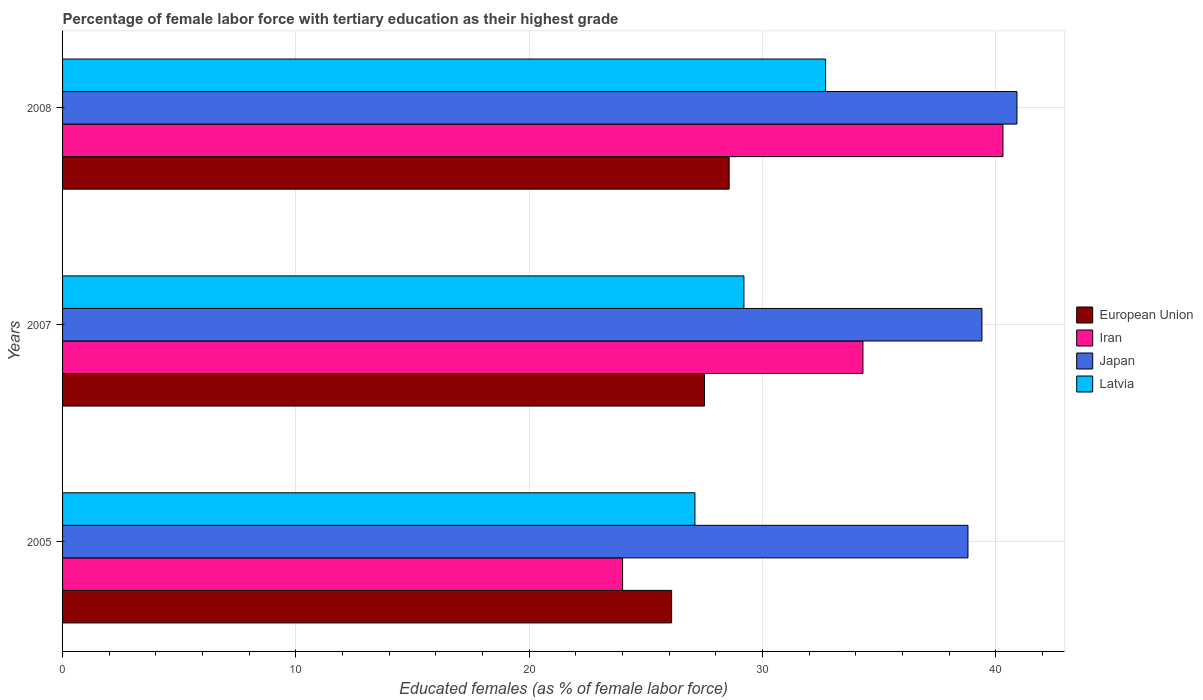How many groups of bars are there?
Your answer should be compact. 3. Are the number of bars per tick equal to the number of legend labels?
Your answer should be very brief. Yes. How many bars are there on the 2nd tick from the top?
Your response must be concise. 4. How many bars are there on the 1st tick from the bottom?
Offer a very short reply. 4. What is the label of the 1st group of bars from the top?
Give a very brief answer. 2008. In how many cases, is the number of bars for a given year not equal to the number of legend labels?
Offer a very short reply. 0. What is the percentage of female labor force with tertiary education in European Union in 2008?
Offer a terse response. 28.57. Across all years, what is the maximum percentage of female labor force with tertiary education in Iran?
Provide a short and direct response. 40.3. In which year was the percentage of female labor force with tertiary education in Latvia maximum?
Offer a terse response. 2008. In which year was the percentage of female labor force with tertiary education in Japan minimum?
Make the answer very short. 2005. What is the total percentage of female labor force with tertiary education in Latvia in the graph?
Keep it short and to the point. 89. What is the difference between the percentage of female labor force with tertiary education in European Union in 2007 and that in 2008?
Your answer should be compact. -1.06. What is the average percentage of female labor force with tertiary education in Iran per year?
Offer a very short reply. 32.87. In the year 2005, what is the difference between the percentage of female labor force with tertiary education in European Union and percentage of female labor force with tertiary education in Japan?
Keep it short and to the point. -12.7. What is the ratio of the percentage of female labor force with tertiary education in Latvia in 2005 to that in 2007?
Provide a short and direct response. 0.93. Is the percentage of female labor force with tertiary education in European Union in 2007 less than that in 2008?
Make the answer very short. Yes. Is the difference between the percentage of female labor force with tertiary education in European Union in 2005 and 2008 greater than the difference between the percentage of female labor force with tertiary education in Japan in 2005 and 2008?
Give a very brief answer. No. What is the difference between the highest and the second highest percentage of female labor force with tertiary education in Latvia?
Ensure brevity in your answer.  3.5. What is the difference between the highest and the lowest percentage of female labor force with tertiary education in Latvia?
Keep it short and to the point. 5.6. Is the sum of the percentage of female labor force with tertiary education in Iran in 2005 and 2008 greater than the maximum percentage of female labor force with tertiary education in European Union across all years?
Give a very brief answer. Yes. Is it the case that in every year, the sum of the percentage of female labor force with tertiary education in Latvia and percentage of female labor force with tertiary education in Japan is greater than the sum of percentage of female labor force with tertiary education in European Union and percentage of female labor force with tertiary education in Iran?
Offer a terse response. No. What does the 1st bar from the top in 2005 represents?
Offer a terse response. Latvia. What does the 2nd bar from the bottom in 2007 represents?
Offer a very short reply. Iran. How many bars are there?
Provide a short and direct response. 12. Are all the bars in the graph horizontal?
Provide a short and direct response. Yes. How many years are there in the graph?
Provide a succinct answer. 3. Are the values on the major ticks of X-axis written in scientific E-notation?
Ensure brevity in your answer.  No. Does the graph contain any zero values?
Your answer should be compact. No. How many legend labels are there?
Make the answer very short. 4. What is the title of the graph?
Keep it short and to the point. Percentage of female labor force with tertiary education as their highest grade. Does "American Samoa" appear as one of the legend labels in the graph?
Provide a succinct answer. No. What is the label or title of the X-axis?
Keep it short and to the point. Educated females (as % of female labor force). What is the Educated females (as % of female labor force) in European Union in 2005?
Give a very brief answer. 26.1. What is the Educated females (as % of female labor force) of Iran in 2005?
Ensure brevity in your answer.  24. What is the Educated females (as % of female labor force) of Japan in 2005?
Offer a terse response. 38.8. What is the Educated females (as % of female labor force) of Latvia in 2005?
Ensure brevity in your answer.  27.1. What is the Educated females (as % of female labor force) in European Union in 2007?
Your response must be concise. 27.51. What is the Educated females (as % of female labor force) in Iran in 2007?
Keep it short and to the point. 34.3. What is the Educated females (as % of female labor force) of Japan in 2007?
Keep it short and to the point. 39.4. What is the Educated females (as % of female labor force) in Latvia in 2007?
Offer a very short reply. 29.2. What is the Educated females (as % of female labor force) of European Union in 2008?
Ensure brevity in your answer.  28.57. What is the Educated females (as % of female labor force) in Iran in 2008?
Your answer should be compact. 40.3. What is the Educated females (as % of female labor force) of Japan in 2008?
Make the answer very short. 40.9. What is the Educated females (as % of female labor force) of Latvia in 2008?
Keep it short and to the point. 32.7. Across all years, what is the maximum Educated females (as % of female labor force) of European Union?
Your response must be concise. 28.57. Across all years, what is the maximum Educated females (as % of female labor force) of Iran?
Keep it short and to the point. 40.3. Across all years, what is the maximum Educated females (as % of female labor force) in Japan?
Your response must be concise. 40.9. Across all years, what is the maximum Educated females (as % of female labor force) of Latvia?
Give a very brief answer. 32.7. Across all years, what is the minimum Educated females (as % of female labor force) of European Union?
Ensure brevity in your answer.  26.1. Across all years, what is the minimum Educated females (as % of female labor force) in Japan?
Offer a very short reply. 38.8. Across all years, what is the minimum Educated females (as % of female labor force) in Latvia?
Make the answer very short. 27.1. What is the total Educated females (as % of female labor force) in European Union in the graph?
Provide a short and direct response. 82.18. What is the total Educated females (as % of female labor force) of Iran in the graph?
Offer a terse response. 98.6. What is the total Educated females (as % of female labor force) in Japan in the graph?
Keep it short and to the point. 119.1. What is the total Educated females (as % of female labor force) in Latvia in the graph?
Your response must be concise. 89. What is the difference between the Educated females (as % of female labor force) of European Union in 2005 and that in 2007?
Provide a short and direct response. -1.41. What is the difference between the Educated females (as % of female labor force) in Iran in 2005 and that in 2007?
Offer a very short reply. -10.3. What is the difference between the Educated females (as % of female labor force) of Japan in 2005 and that in 2007?
Keep it short and to the point. -0.6. What is the difference between the Educated females (as % of female labor force) in Latvia in 2005 and that in 2007?
Offer a very short reply. -2.1. What is the difference between the Educated females (as % of female labor force) of European Union in 2005 and that in 2008?
Offer a very short reply. -2.46. What is the difference between the Educated females (as % of female labor force) in Iran in 2005 and that in 2008?
Make the answer very short. -16.3. What is the difference between the Educated females (as % of female labor force) in Japan in 2005 and that in 2008?
Make the answer very short. -2.1. What is the difference between the Educated females (as % of female labor force) of Latvia in 2005 and that in 2008?
Your response must be concise. -5.6. What is the difference between the Educated females (as % of female labor force) in European Union in 2007 and that in 2008?
Ensure brevity in your answer.  -1.06. What is the difference between the Educated females (as % of female labor force) of Iran in 2007 and that in 2008?
Keep it short and to the point. -6. What is the difference between the Educated females (as % of female labor force) of Japan in 2007 and that in 2008?
Make the answer very short. -1.5. What is the difference between the Educated females (as % of female labor force) of European Union in 2005 and the Educated females (as % of female labor force) of Iran in 2007?
Give a very brief answer. -8.2. What is the difference between the Educated females (as % of female labor force) in European Union in 2005 and the Educated females (as % of female labor force) in Japan in 2007?
Offer a very short reply. -13.3. What is the difference between the Educated females (as % of female labor force) of European Union in 2005 and the Educated females (as % of female labor force) of Latvia in 2007?
Give a very brief answer. -3.1. What is the difference between the Educated females (as % of female labor force) of Iran in 2005 and the Educated females (as % of female labor force) of Japan in 2007?
Your answer should be very brief. -15.4. What is the difference between the Educated females (as % of female labor force) in Iran in 2005 and the Educated females (as % of female labor force) in Latvia in 2007?
Your answer should be compact. -5.2. What is the difference between the Educated females (as % of female labor force) of European Union in 2005 and the Educated females (as % of female labor force) of Iran in 2008?
Keep it short and to the point. -14.2. What is the difference between the Educated females (as % of female labor force) of European Union in 2005 and the Educated females (as % of female labor force) of Japan in 2008?
Your response must be concise. -14.8. What is the difference between the Educated females (as % of female labor force) in European Union in 2005 and the Educated females (as % of female labor force) in Latvia in 2008?
Provide a succinct answer. -6.6. What is the difference between the Educated females (as % of female labor force) in Iran in 2005 and the Educated females (as % of female labor force) in Japan in 2008?
Offer a very short reply. -16.9. What is the difference between the Educated females (as % of female labor force) in European Union in 2007 and the Educated females (as % of female labor force) in Iran in 2008?
Provide a short and direct response. -12.79. What is the difference between the Educated females (as % of female labor force) in European Union in 2007 and the Educated females (as % of female labor force) in Japan in 2008?
Your response must be concise. -13.39. What is the difference between the Educated females (as % of female labor force) in European Union in 2007 and the Educated females (as % of female labor force) in Latvia in 2008?
Offer a very short reply. -5.19. What is the difference between the Educated females (as % of female labor force) of Iran in 2007 and the Educated females (as % of female labor force) of Japan in 2008?
Provide a short and direct response. -6.6. What is the difference between the Educated females (as % of female labor force) of Japan in 2007 and the Educated females (as % of female labor force) of Latvia in 2008?
Your answer should be very brief. 6.7. What is the average Educated females (as % of female labor force) in European Union per year?
Your answer should be very brief. 27.39. What is the average Educated females (as % of female labor force) of Iran per year?
Your answer should be very brief. 32.87. What is the average Educated females (as % of female labor force) in Japan per year?
Keep it short and to the point. 39.7. What is the average Educated females (as % of female labor force) in Latvia per year?
Your answer should be compact. 29.67. In the year 2005, what is the difference between the Educated females (as % of female labor force) of European Union and Educated females (as % of female labor force) of Iran?
Keep it short and to the point. 2.1. In the year 2005, what is the difference between the Educated females (as % of female labor force) in European Union and Educated females (as % of female labor force) in Japan?
Your answer should be very brief. -12.7. In the year 2005, what is the difference between the Educated females (as % of female labor force) of European Union and Educated females (as % of female labor force) of Latvia?
Ensure brevity in your answer.  -1. In the year 2005, what is the difference between the Educated females (as % of female labor force) of Iran and Educated females (as % of female labor force) of Japan?
Make the answer very short. -14.8. In the year 2005, what is the difference between the Educated females (as % of female labor force) in Iran and Educated females (as % of female labor force) in Latvia?
Make the answer very short. -3.1. In the year 2005, what is the difference between the Educated females (as % of female labor force) of Japan and Educated females (as % of female labor force) of Latvia?
Keep it short and to the point. 11.7. In the year 2007, what is the difference between the Educated females (as % of female labor force) of European Union and Educated females (as % of female labor force) of Iran?
Your answer should be compact. -6.79. In the year 2007, what is the difference between the Educated females (as % of female labor force) in European Union and Educated females (as % of female labor force) in Japan?
Offer a terse response. -11.89. In the year 2007, what is the difference between the Educated females (as % of female labor force) in European Union and Educated females (as % of female labor force) in Latvia?
Ensure brevity in your answer.  -1.69. In the year 2007, what is the difference between the Educated females (as % of female labor force) in Iran and Educated females (as % of female labor force) in Latvia?
Provide a succinct answer. 5.1. In the year 2008, what is the difference between the Educated females (as % of female labor force) in European Union and Educated females (as % of female labor force) in Iran?
Keep it short and to the point. -11.73. In the year 2008, what is the difference between the Educated females (as % of female labor force) of European Union and Educated females (as % of female labor force) of Japan?
Provide a succinct answer. -12.33. In the year 2008, what is the difference between the Educated females (as % of female labor force) of European Union and Educated females (as % of female labor force) of Latvia?
Make the answer very short. -4.13. In the year 2008, what is the difference between the Educated females (as % of female labor force) of Iran and Educated females (as % of female labor force) of Japan?
Your answer should be compact. -0.6. In the year 2008, what is the difference between the Educated females (as % of female labor force) in Japan and Educated females (as % of female labor force) in Latvia?
Provide a short and direct response. 8.2. What is the ratio of the Educated females (as % of female labor force) in European Union in 2005 to that in 2007?
Ensure brevity in your answer.  0.95. What is the ratio of the Educated females (as % of female labor force) of Iran in 2005 to that in 2007?
Keep it short and to the point. 0.7. What is the ratio of the Educated females (as % of female labor force) of Latvia in 2005 to that in 2007?
Ensure brevity in your answer.  0.93. What is the ratio of the Educated females (as % of female labor force) of European Union in 2005 to that in 2008?
Your response must be concise. 0.91. What is the ratio of the Educated females (as % of female labor force) of Iran in 2005 to that in 2008?
Provide a short and direct response. 0.6. What is the ratio of the Educated females (as % of female labor force) in Japan in 2005 to that in 2008?
Offer a very short reply. 0.95. What is the ratio of the Educated females (as % of female labor force) of Latvia in 2005 to that in 2008?
Ensure brevity in your answer.  0.83. What is the ratio of the Educated females (as % of female labor force) in European Union in 2007 to that in 2008?
Your answer should be compact. 0.96. What is the ratio of the Educated females (as % of female labor force) in Iran in 2007 to that in 2008?
Your answer should be very brief. 0.85. What is the ratio of the Educated females (as % of female labor force) of Japan in 2007 to that in 2008?
Your answer should be compact. 0.96. What is the ratio of the Educated females (as % of female labor force) of Latvia in 2007 to that in 2008?
Make the answer very short. 0.89. What is the difference between the highest and the second highest Educated females (as % of female labor force) of European Union?
Offer a very short reply. 1.06. What is the difference between the highest and the second highest Educated females (as % of female labor force) in Japan?
Your response must be concise. 1.5. What is the difference between the highest and the lowest Educated females (as % of female labor force) in European Union?
Ensure brevity in your answer.  2.46. What is the difference between the highest and the lowest Educated females (as % of female labor force) of Iran?
Make the answer very short. 16.3. What is the difference between the highest and the lowest Educated females (as % of female labor force) in Japan?
Provide a succinct answer. 2.1. 